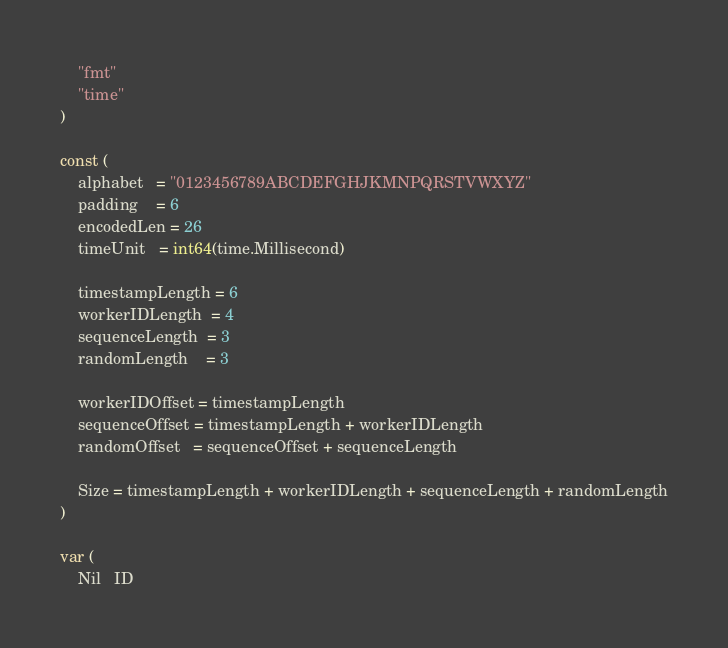Convert code to text. <code><loc_0><loc_0><loc_500><loc_500><_Go_>	"fmt"
	"time"
)

const (
	alphabet   = "0123456789ABCDEFGHJKMNPQRSTVWXYZ"
	padding    = 6
	encodedLen = 26
	timeUnit   = int64(time.Millisecond)

	timestampLength = 6
	workerIDLength  = 4
	sequenceLength  = 3
	randomLength    = 3

	workerIDOffset = timestampLength
	sequenceOffset = timestampLength + workerIDLength
	randomOffset   = sequenceOffset + sequenceLength

	Size = timestampLength + workerIDLength + sequenceLength + randomLength
)

var (
	Nil   ID</code> 